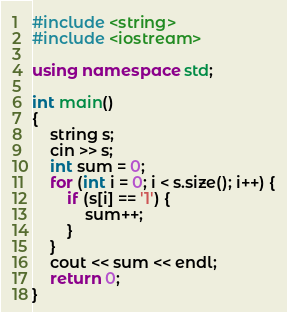Convert code to text. <code><loc_0><loc_0><loc_500><loc_500><_C++_>#include <string>
#include <iostream>

using namespace std;

int main()
{
	string s;
	cin >> s;
	int sum = 0;
	for (int i = 0; i < s.size(); i++) {
		if (s[i] == '1') {
			sum++;
		}
	}
	cout << sum << endl;
	return 0;
}</code> 